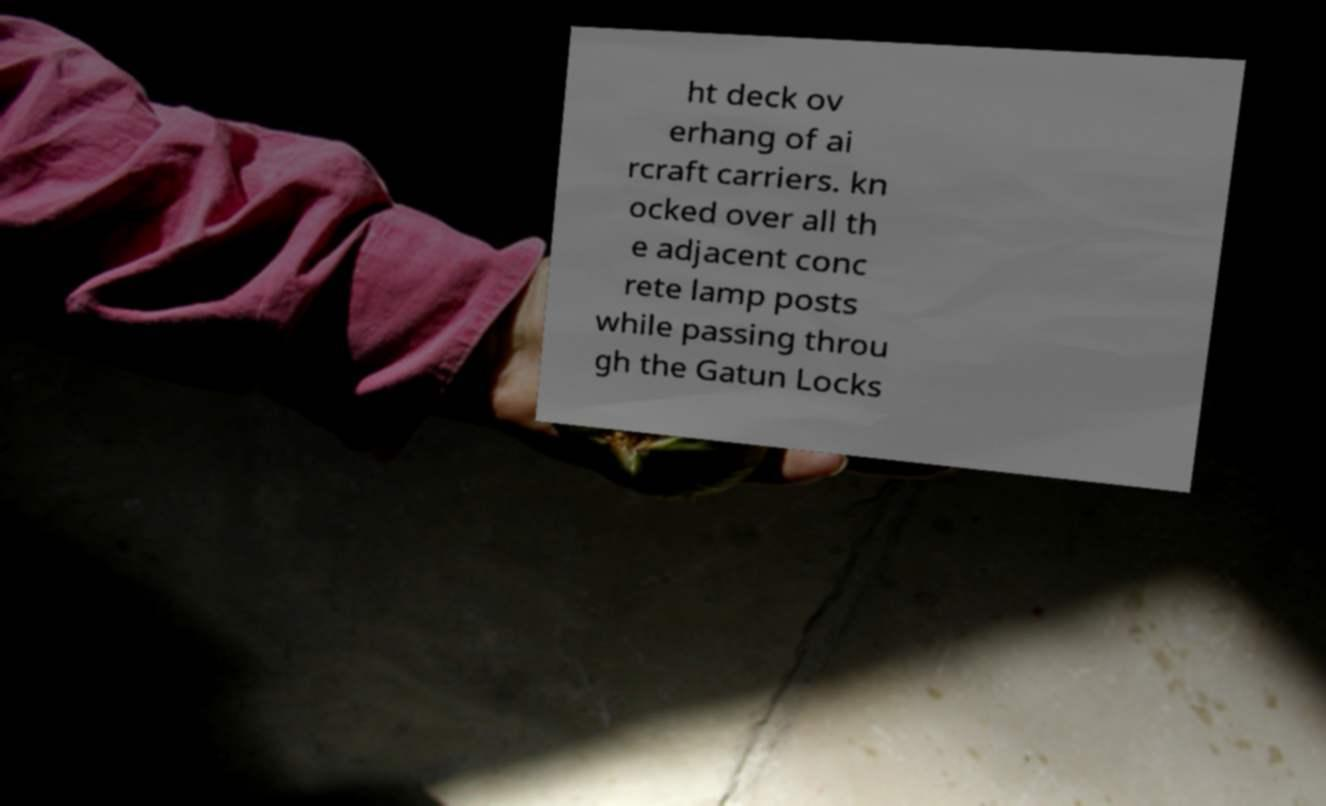Please read and relay the text visible in this image. What does it say? ht deck ov erhang of ai rcraft carriers. kn ocked over all th e adjacent conc rete lamp posts while passing throu gh the Gatun Locks 